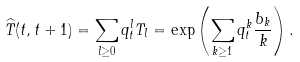<formula> <loc_0><loc_0><loc_500><loc_500>\widehat { T } ( t , t + 1 ) = \sum _ { l \geq 0 } { q _ { t } ^ { l } T _ { l } } = \exp \left ( \sum _ { k \geq 1 } { q _ { t } ^ { k } \frac { b _ { k } } { k } } \right ) .</formula> 